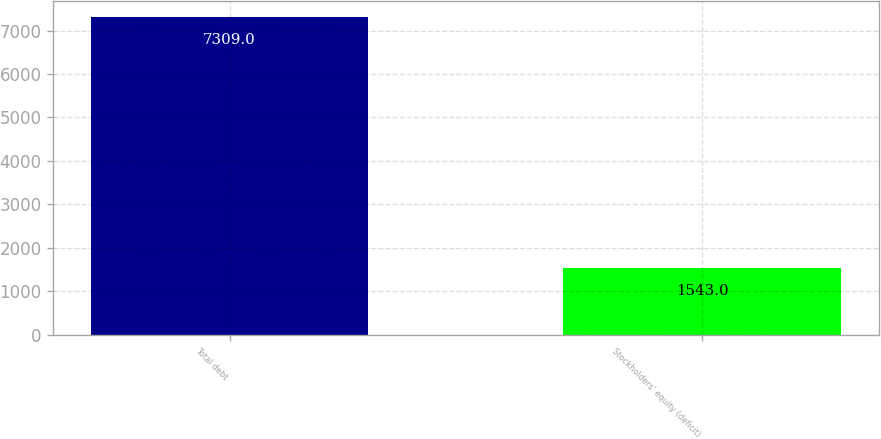<chart> <loc_0><loc_0><loc_500><loc_500><bar_chart><fcel>Total debt<fcel>Stockholders' equity (deficit)<nl><fcel>7309<fcel>1543<nl></chart> 